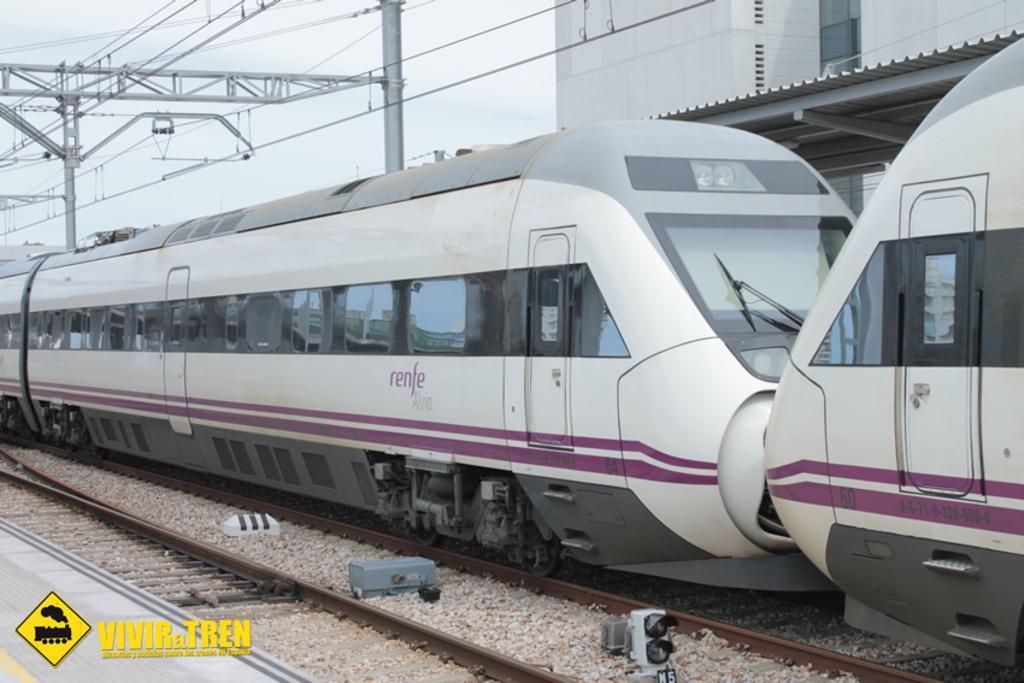Can you describe this image briefly? As we can see in the image there is a metro, track, current polls, building and sky. 